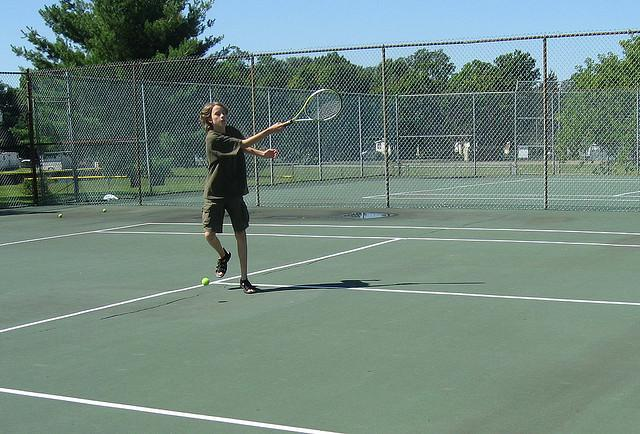What did the boy most likely just do to the ball with his racket? Please explain your reasoning. missed it. You can tell by the position of the ball that he missed it. 